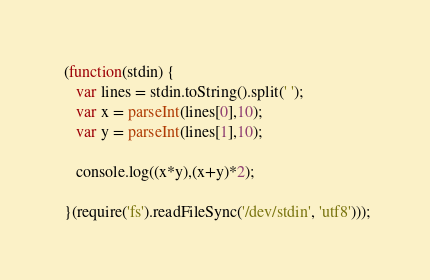Convert code to text. <code><loc_0><loc_0><loc_500><loc_500><_JavaScript_> (function(stdin) {
    var lines = stdin.toString().split(' ');
    var x = parseInt(lines[0],10);
    var y = parseInt(lines[1],10);
    
    console.log((x*y),(x+y)*2);

 }(require('fs').readFileSync('/dev/stdin', 'utf8')));</code> 